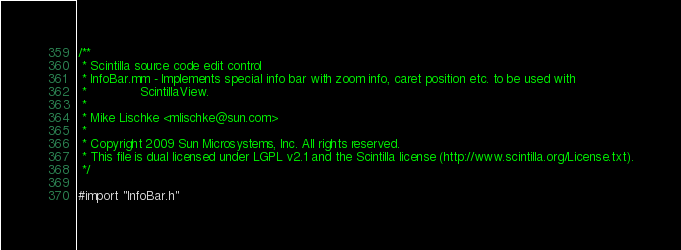<code> <loc_0><loc_0><loc_500><loc_500><_ObjectiveC_>
/**
 * Scintilla source code edit control
 * InfoBar.mm - Implements special info bar with zoom info, caret position etc. to be used with
 *              ScintillaView.
 *
 * Mike Lischke <mlischke@sun.com>
 *
 * Copyright 2009 Sun Microsystems, Inc. All rights reserved.
 * This file is dual licensed under LGPL v2.1 and the Scintilla license (http://www.scintilla.org/License.txt).
 */

#import "InfoBar.h"
</code> 